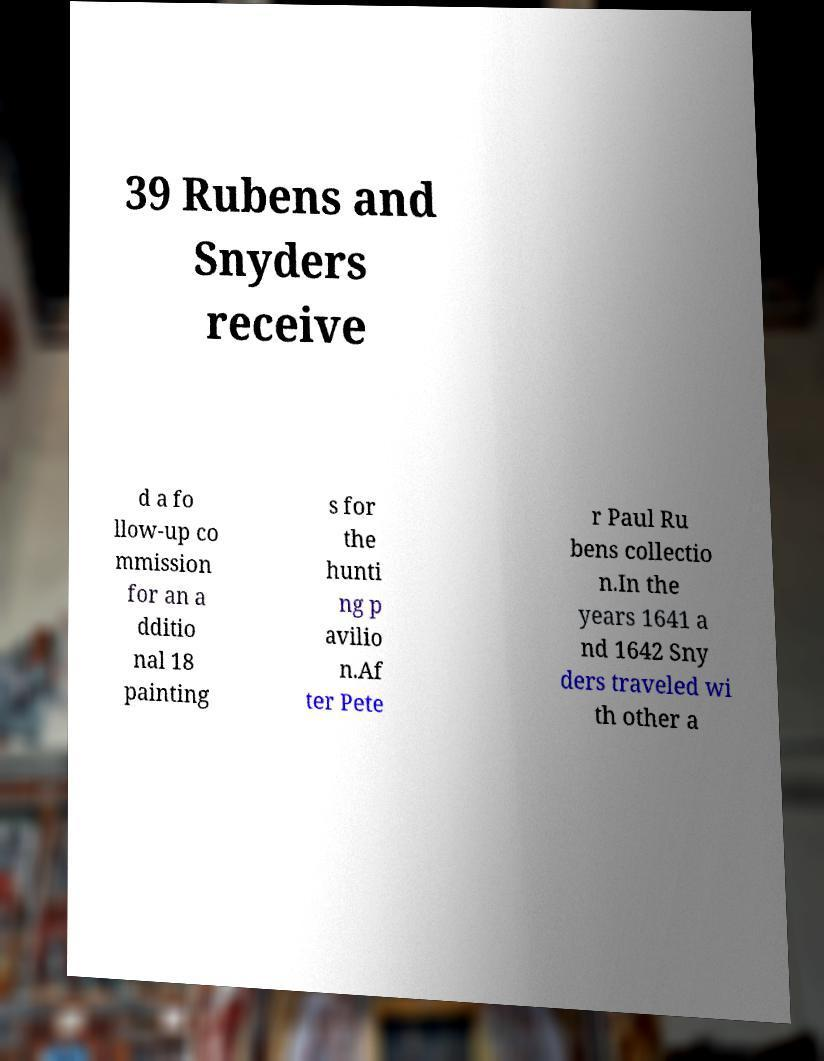I need the written content from this picture converted into text. Can you do that? 39 Rubens and Snyders receive d a fo llow-up co mmission for an a dditio nal 18 painting s for the hunti ng p avilio n.Af ter Pete r Paul Ru bens collectio n.In the years 1641 a nd 1642 Sny ders traveled wi th other a 